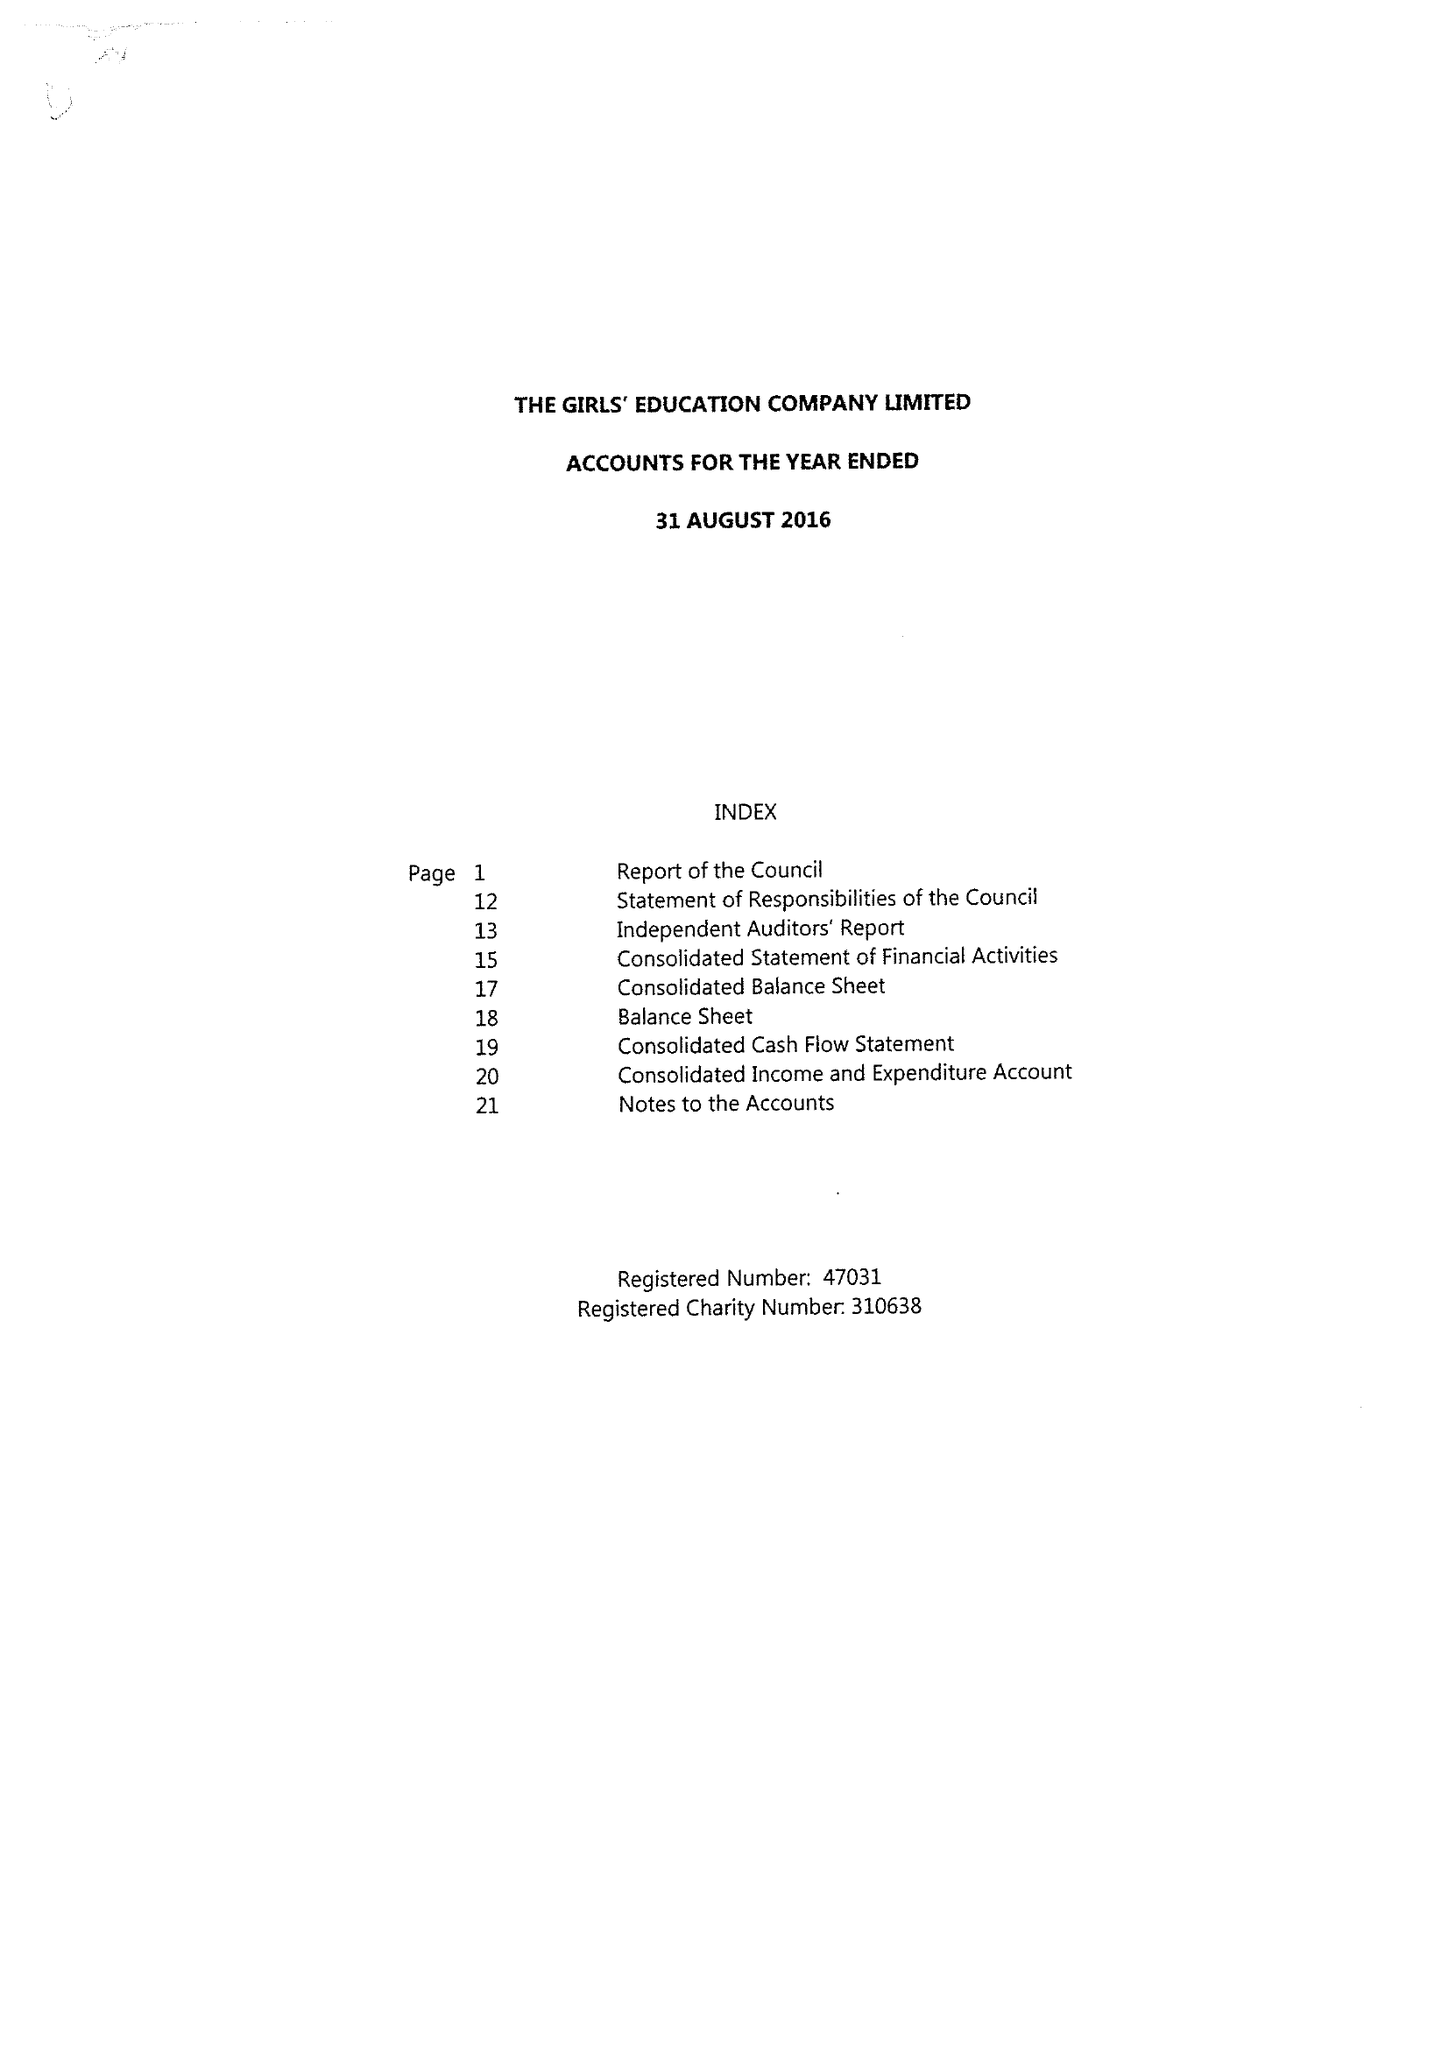What is the value for the address__street_line?
Answer the question using a single word or phrase. ABBEY WAY 